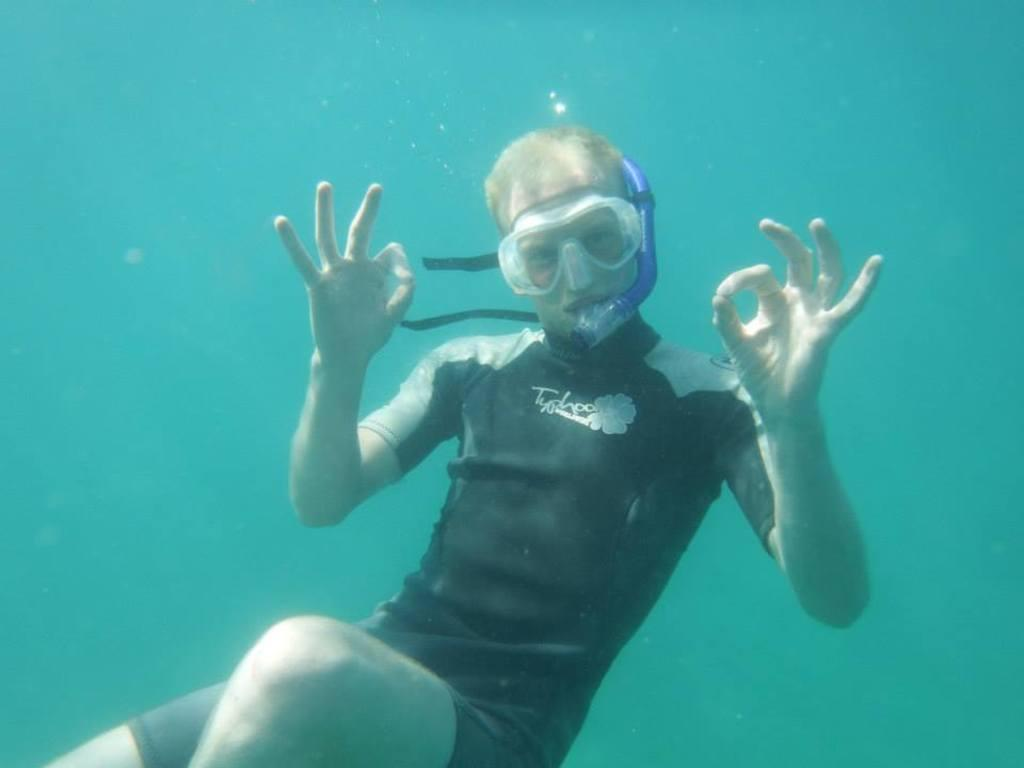Where is the image taken? The image is taken in the water. Who is present in the image? There is a man in the image. What is the man wearing? The man is wearing a black color shirt. What can be seen in the background of the image? There is water visible in the background of the image. What type of alarm can be heard going off in the image? There is no alarm present in the image, as it is a photograph taken in the water with a man wearing a black shirt. 